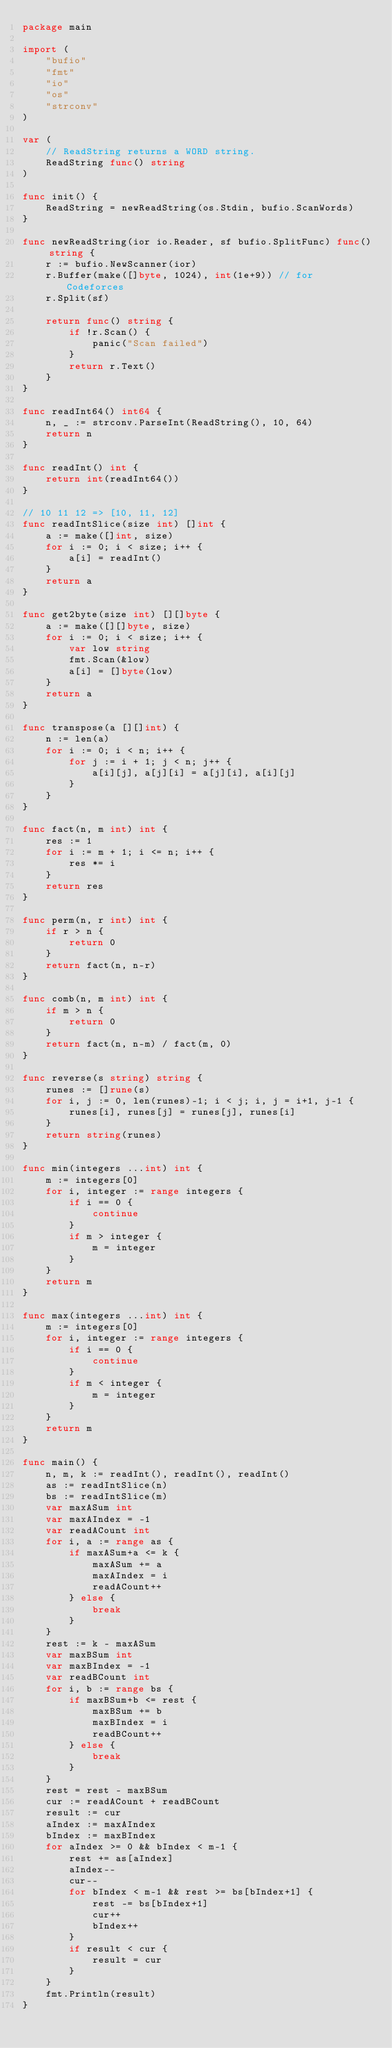<code> <loc_0><loc_0><loc_500><loc_500><_Go_>package main

import (
	"bufio"
	"fmt"
	"io"
	"os"
	"strconv"
)

var (
	// ReadString returns a WORD string.
	ReadString func() string
)

func init() {
	ReadString = newReadString(os.Stdin, bufio.ScanWords)
}

func newReadString(ior io.Reader, sf bufio.SplitFunc) func() string {
	r := bufio.NewScanner(ior)
	r.Buffer(make([]byte, 1024), int(1e+9)) // for Codeforces
	r.Split(sf)

	return func() string {
		if !r.Scan() {
			panic("Scan failed")
		}
		return r.Text()
	}
}

func readInt64() int64 {
	n, _ := strconv.ParseInt(ReadString(), 10, 64)
	return n
}

func readInt() int {
	return int(readInt64())
}

// 10 11 12 => [10, 11, 12]
func readIntSlice(size int) []int {
	a := make([]int, size)
	for i := 0; i < size; i++ {
		a[i] = readInt()
	}
	return a
}

func get2byte(size int) [][]byte {
	a := make([][]byte, size)
	for i := 0; i < size; i++ {
		var low string
		fmt.Scan(&low)
		a[i] = []byte(low)
	}
	return a
}

func transpose(a [][]int) {
	n := len(a)
	for i := 0; i < n; i++ {
		for j := i + 1; j < n; j++ {
			a[i][j], a[j][i] = a[j][i], a[i][j]
		}
	}
}

func fact(n, m int) int {
	res := 1
	for i := m + 1; i <= n; i++ {
		res *= i
	}
	return res
}

func perm(n, r int) int {
	if r > n {
		return 0
	}
	return fact(n, n-r)
}

func comb(n, m int) int {
	if m > n {
		return 0
	}
	return fact(n, n-m) / fact(m, 0)
}

func reverse(s string) string {
	runes := []rune(s)
	for i, j := 0, len(runes)-1; i < j; i, j = i+1, j-1 {
		runes[i], runes[j] = runes[j], runes[i]
	}
	return string(runes)
}

func min(integers ...int) int {
	m := integers[0]
	for i, integer := range integers {
		if i == 0 {
			continue
		}
		if m > integer {
			m = integer
		}
	}
	return m
}

func max(integers ...int) int {
	m := integers[0]
	for i, integer := range integers {
		if i == 0 {
			continue
		}
		if m < integer {
			m = integer
		}
	}
	return m
}

func main() {
	n, m, k := readInt(), readInt(), readInt()
	as := readIntSlice(n)
	bs := readIntSlice(m)
	var maxASum int
	var maxAIndex = -1
	var readACount int
	for i, a := range as {
		if maxASum+a <= k {
			maxASum += a
			maxAIndex = i
			readACount++
		} else {
			break
		}
	}
	rest := k - maxASum
	var maxBSum int
	var maxBIndex = -1
	var readBCount int
	for i, b := range bs {
		if maxBSum+b <= rest {
			maxBSum += b
			maxBIndex = i
			readBCount++
		} else {
			break
		}
	}
	rest = rest - maxBSum
	cur := readACount + readBCount
	result := cur
	aIndex := maxAIndex
	bIndex := maxBIndex
	for aIndex >= 0 && bIndex < m-1 {
		rest += as[aIndex]
		aIndex--
		cur--
		for bIndex < m-1 && rest >= bs[bIndex+1] {
			rest -= bs[bIndex+1]
			cur++
			bIndex++
		}
		if result < cur {
			result = cur
		}
	}
	fmt.Println(result)
}
</code> 